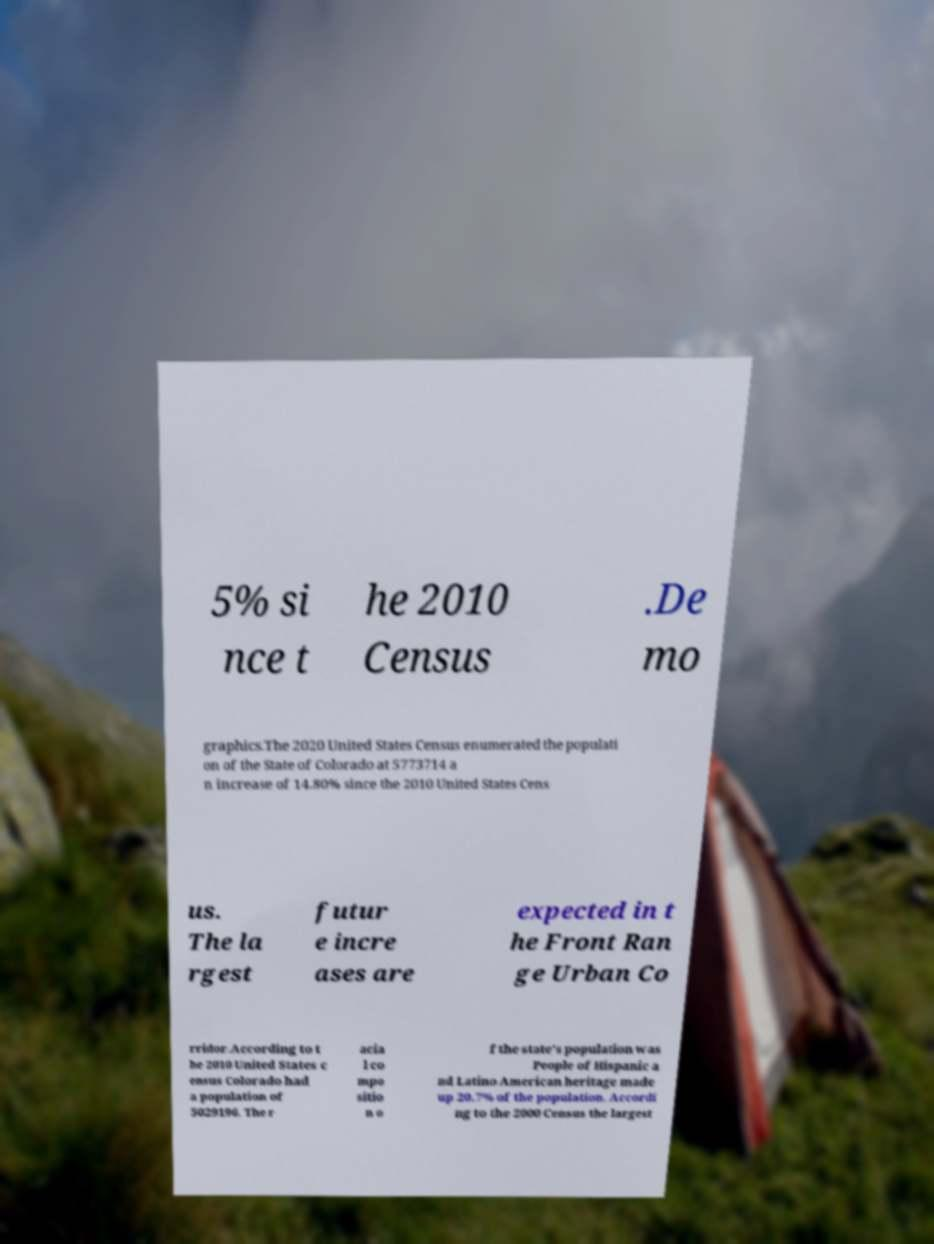Could you assist in decoding the text presented in this image and type it out clearly? 5% si nce t he 2010 Census .De mo graphics.The 2020 United States Census enumerated the populati on of the State of Colorado at 5773714 a n increase of 14.80% since the 2010 United States Cens us. The la rgest futur e incre ases are expected in t he Front Ran ge Urban Co rridor.According to t he 2010 United States c ensus Colorado had a population of 5029196. The r acia l co mpo sitio n o f the state's population was People of Hispanic a nd Latino American heritage made up 20.7% of the population. Accordi ng to the 2000 Census the largest 